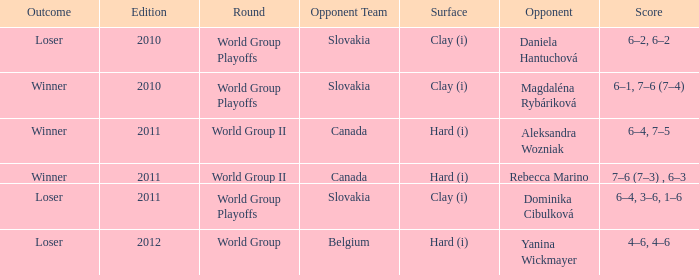What was the score when the opponent was Dominika Cibulková? 6–4, 3–6, 1–6. Write the full table. {'header': ['Outcome', 'Edition', 'Round', 'Opponent Team', 'Surface', 'Opponent', 'Score'], 'rows': [['Loser', '2010', 'World Group Playoffs', 'Slovakia', 'Clay (i)', 'Daniela Hantuchová', '6–2, 6–2'], ['Winner', '2010', 'World Group Playoffs', 'Slovakia', 'Clay (i)', 'Magdaléna Rybáriková', '6–1, 7–6 (7–4)'], ['Winner', '2011', 'World Group II', 'Canada', 'Hard (i)', 'Aleksandra Wozniak', '6–4, 7–5'], ['Winner', '2011', 'World Group II', 'Canada', 'Hard (i)', 'Rebecca Marino', '7–6 (7–3) , 6–3'], ['Loser', '2011', 'World Group Playoffs', 'Slovakia', 'Clay (i)', 'Dominika Cibulková', '6–4, 3–6, 1–6'], ['Loser', '2012', 'World Group', 'Belgium', 'Hard (i)', 'Yanina Wickmayer', '4–6, 4–6']]} 